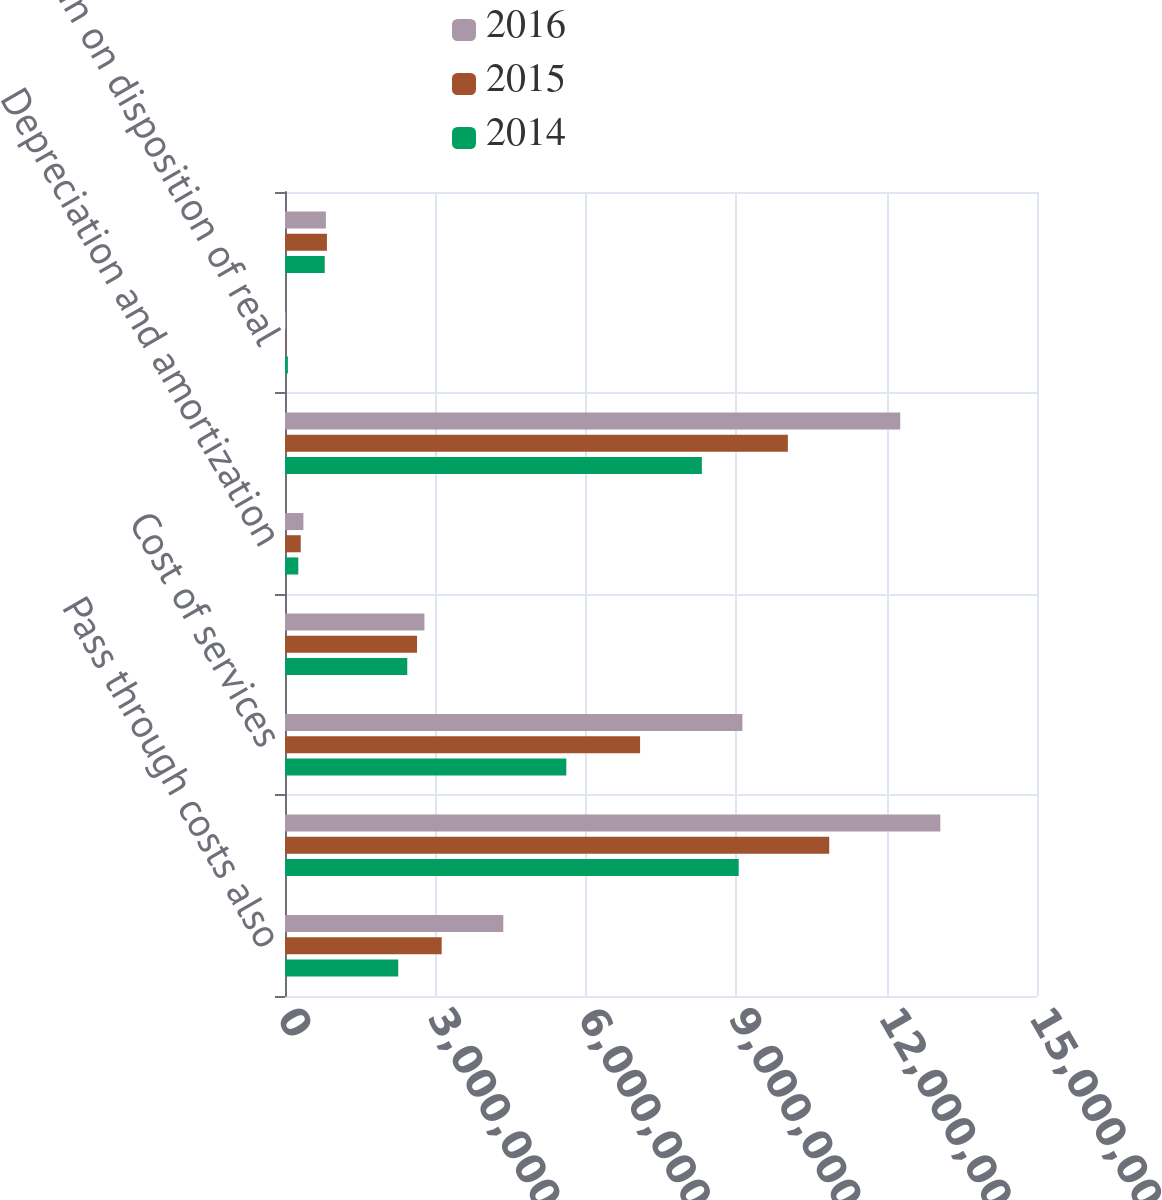Convert chart to OTSL. <chart><loc_0><loc_0><loc_500><loc_500><stacked_bar_chart><ecel><fcel>Pass through costs also<fcel>Total revenue<fcel>Cost of services<fcel>Operating administrative and<fcel>Depreciation and amortization<fcel>Total costs and expenses<fcel>Gain on disposition of real<fcel>Operating income<nl><fcel>2016<fcel>4.35446e+06<fcel>1.30716e+07<fcel>9.12373e+06<fcel>2.78131e+06<fcel>366927<fcel>1.2272e+07<fcel>15862<fcel>815487<nl><fcel>2015<fcel>3.12547e+06<fcel>1.08558e+07<fcel>7.08293e+06<fcel>2.63361e+06<fcel>314096<fcel>1.00306e+07<fcel>10771<fcel>835944<nl><fcel>2014<fcel>2.25863e+06<fcel>9.04992e+06<fcel>5.61126e+06<fcel>2.43896e+06<fcel>265101<fcel>8.31532e+06<fcel>57659<fcel>792254<nl></chart> 